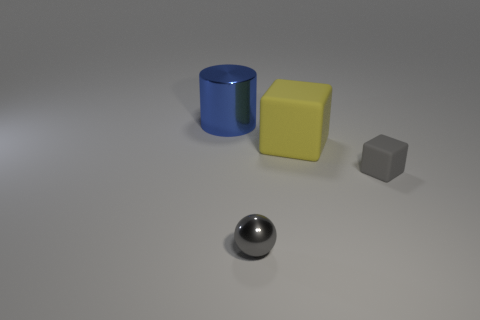Can you describe the lighting and shadows in the scene? The lighting in the image appears to be coming from above, casting soft shadows to the right of the objects. These shadows are subtle and help to enhance the three-dimensional appearance of the objects on the flat surface. 